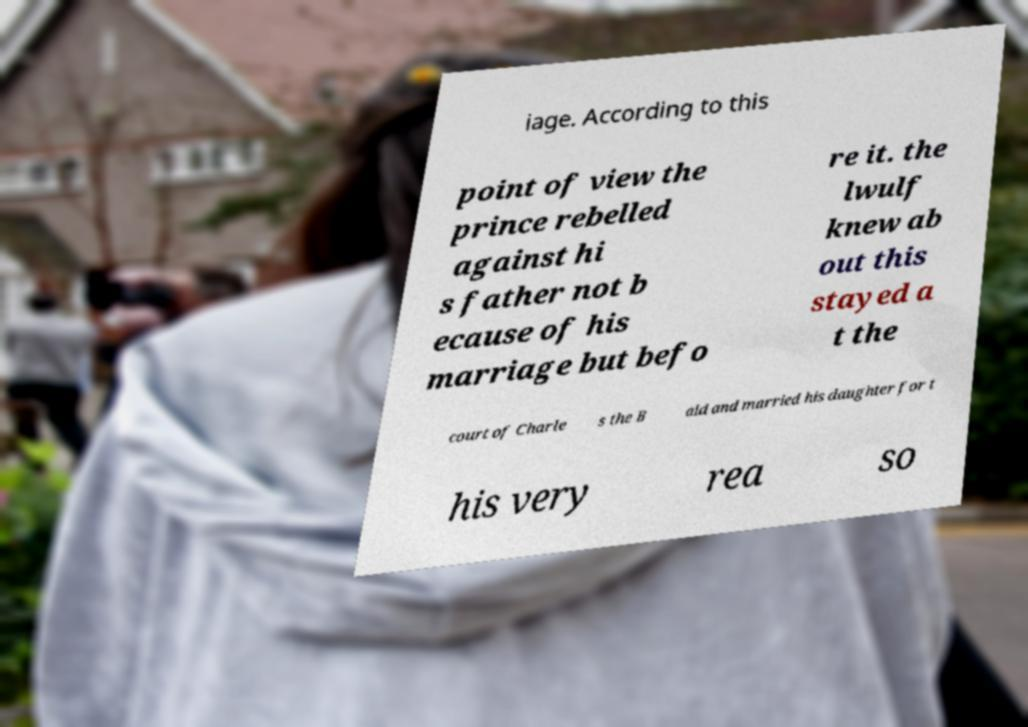I need the written content from this picture converted into text. Can you do that? iage. According to this point of view the prince rebelled against hi s father not b ecause of his marriage but befo re it. the lwulf knew ab out this stayed a t the court of Charle s the B ald and married his daughter for t his very rea so 